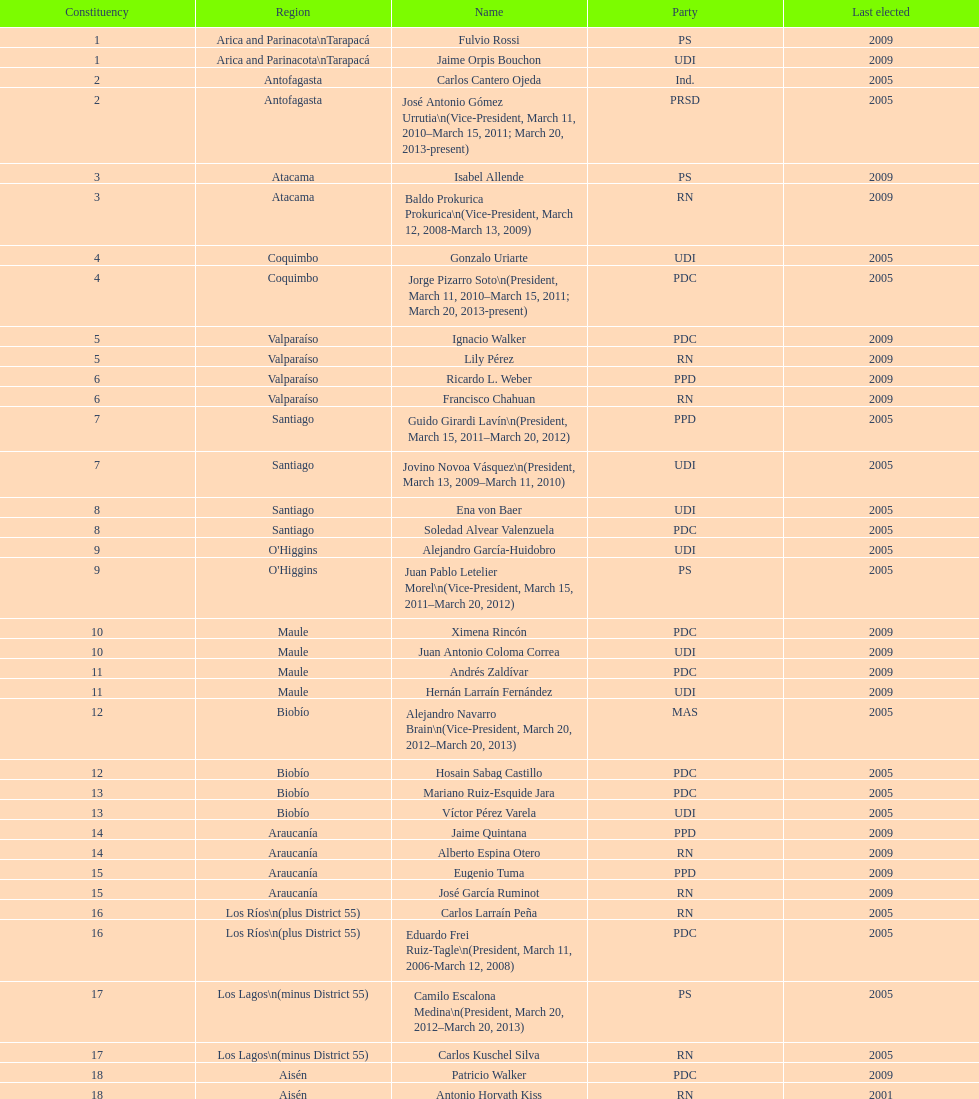What is the final area mentioned in the chart? Magallanes. 